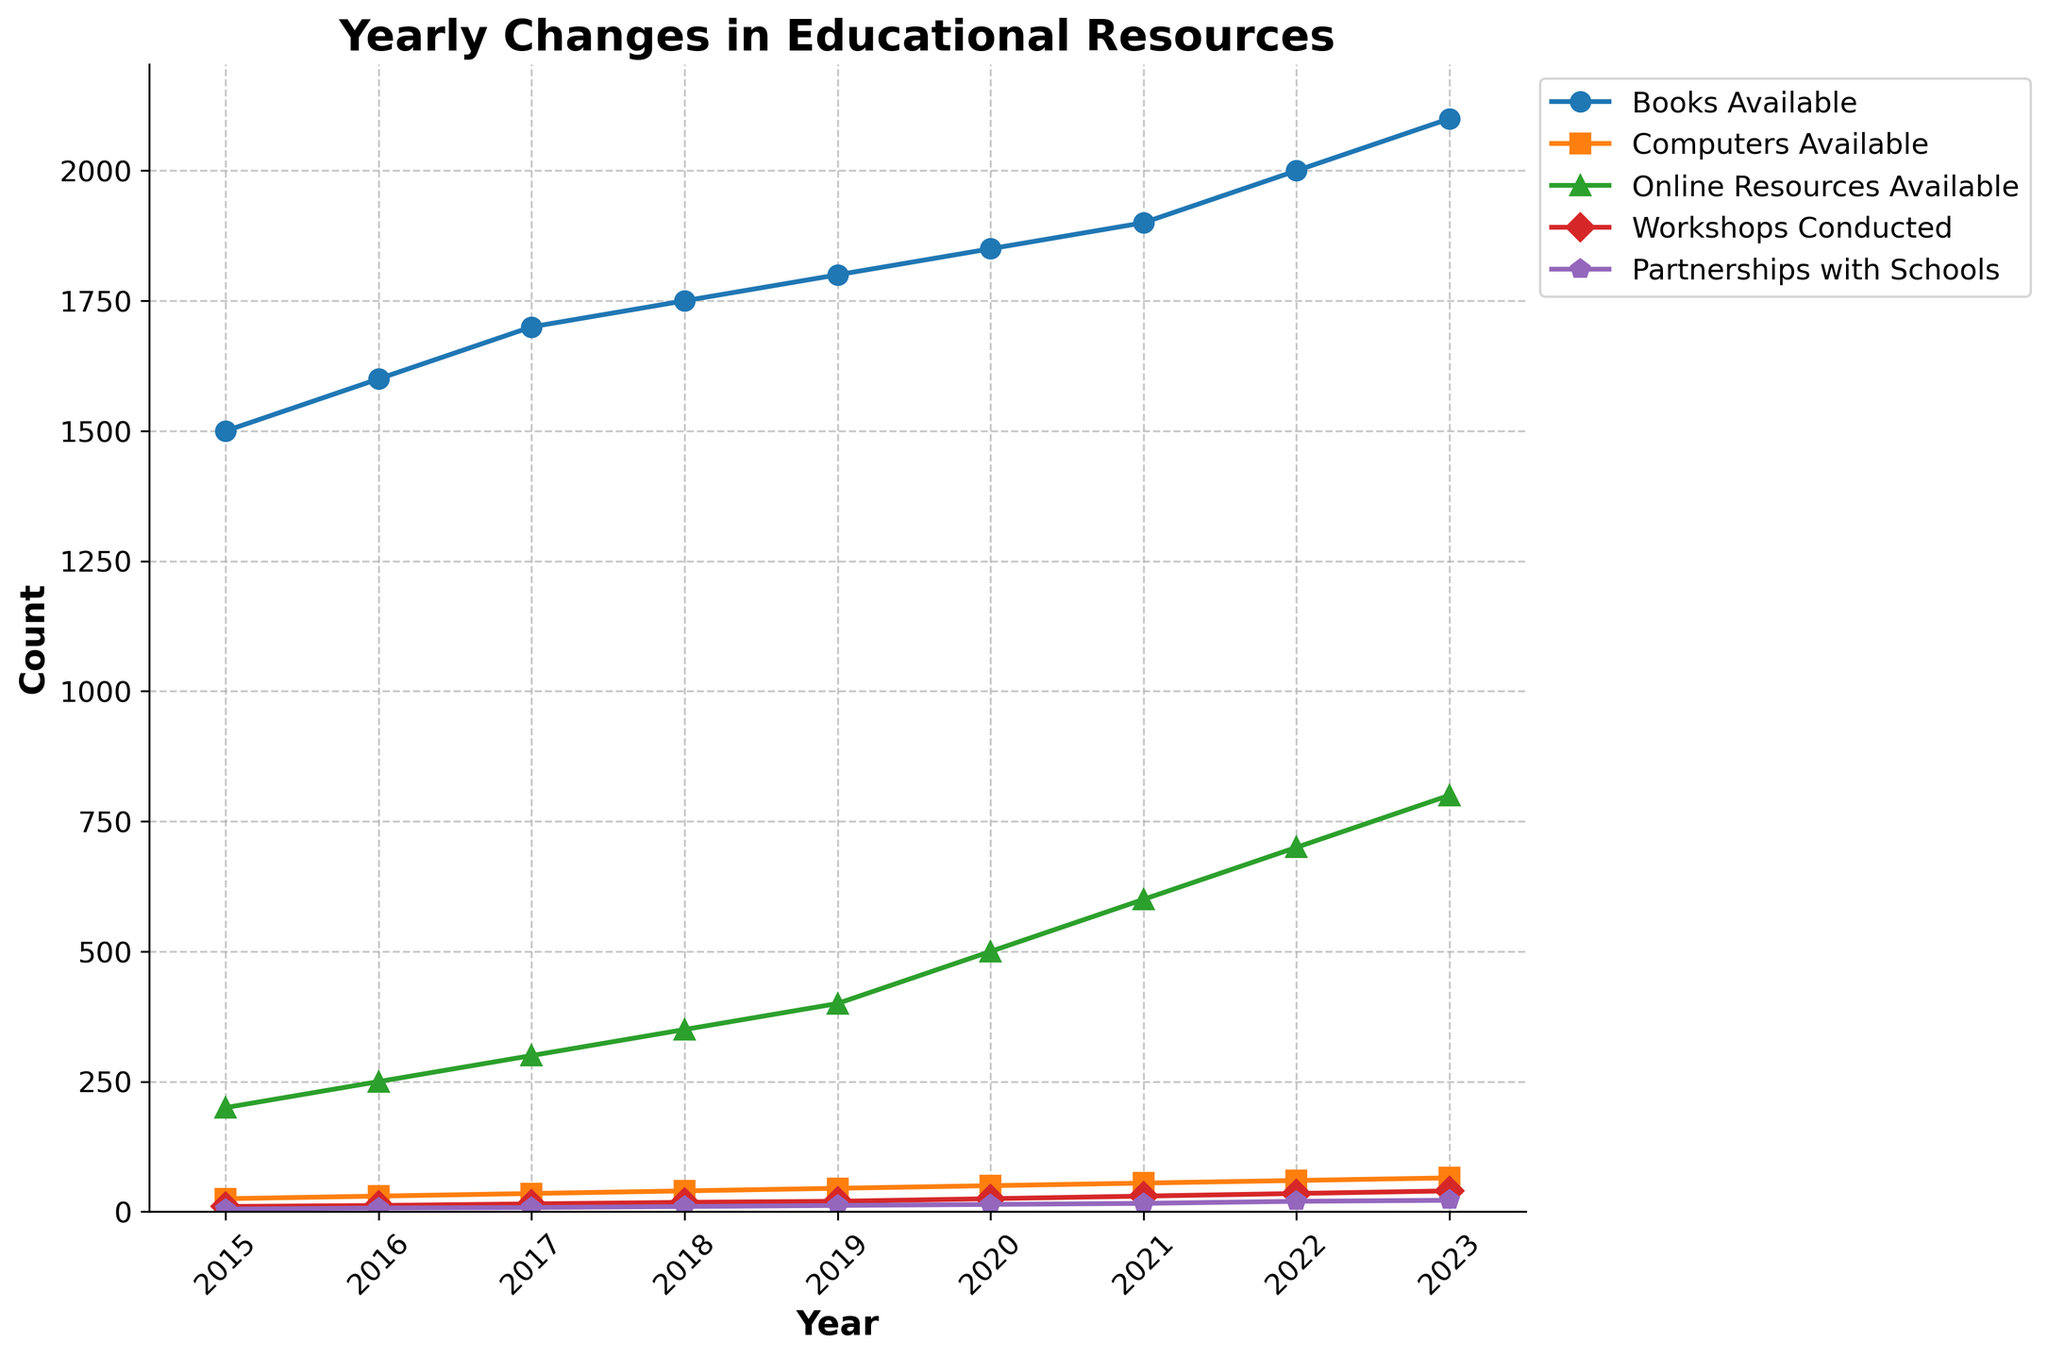What is the title of the plot? The plot title is located at the top of the figure and provides an overview of the data being presented. It should read "Yearly Changes in Educational Resources".
Answer: Yearly Changes in Educational Resources How many different educational resources are tracked in the plot? The plot tracks multiple educational resources which are differentiated by color and labeled in the legend. Count the items in the legend to find the total number.
Answer: 5 What is the trend in the number of Books Available from 2015 to 2023? To find the trend, observe the curve corresponding to Books Available from the leftmost point (2015) to the rightmost point (2023).
Answer: Increasing How many more Online Resources were available in 2023 compared to 2015? Look at the y-values for Online Resources Available in 2023 and 2015. Subtract the 2015 value from the 2023 value: 800 - 200.
Answer: 600 Which resource showed the largest increase in absolute numbers between 2015 and 2023? Compare the increases for all resources by subtracting the 2015 value from the 2023 value for each and finding the largest difference.
Answer: Online Resources Available What was the average number of Workshops Conducted per year from 2015 to 2023? Add the total number of Workshops Conducted over the years and divide by the number of years. Sum (10+12+15+18+20+25+30+35+40)/9.
Answer: 22.78 Which year had an equal number of Computers Available and Books Available? Compare the y-values for Computers Available and Books Available across all years. None appear to match precisely, so there is no such year.
Answer: None Which resource shows a steady year-on-year increase without any dips? Observe each line for any drops in value between consecutive years. The line with no such drops is the one being asked for.
Answer: Books Available Between which consecutive years did the number of Partnerships with Schools increase the most? Find the difference in Partnerships with Schools for each pair of consecutive years and identify the pair with the largest increase. (2020 to 2021: 16 - 14 = 2, 2021 to 2022: 20 - 16 = 4).
Answer: 2021 to 2022 In what year did Computers Available first exceed 50 units? Identify the year on the x-axis corresponding to the first point in the Computers Available curve that is above 50.
Answer: 2020 